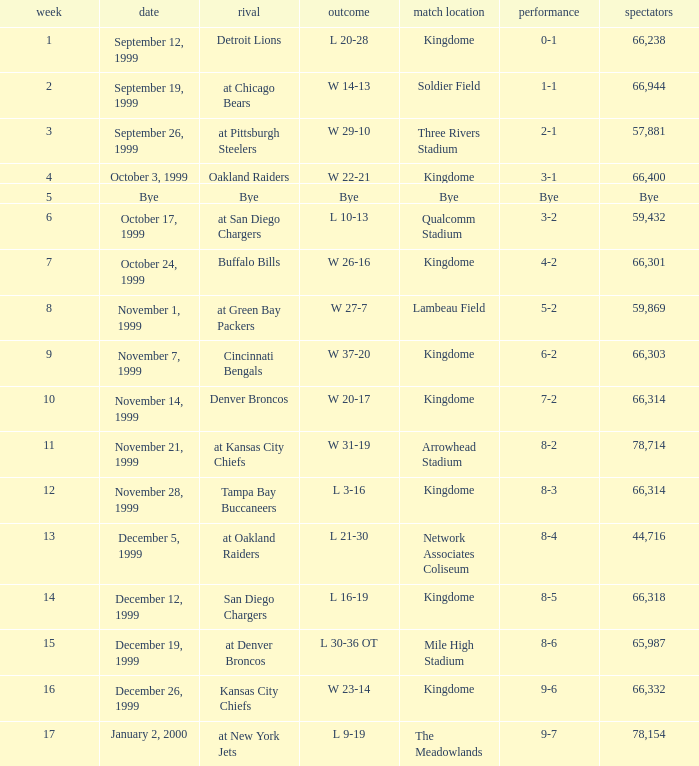For the game that was played on week 2, what is the record? 1-1. 